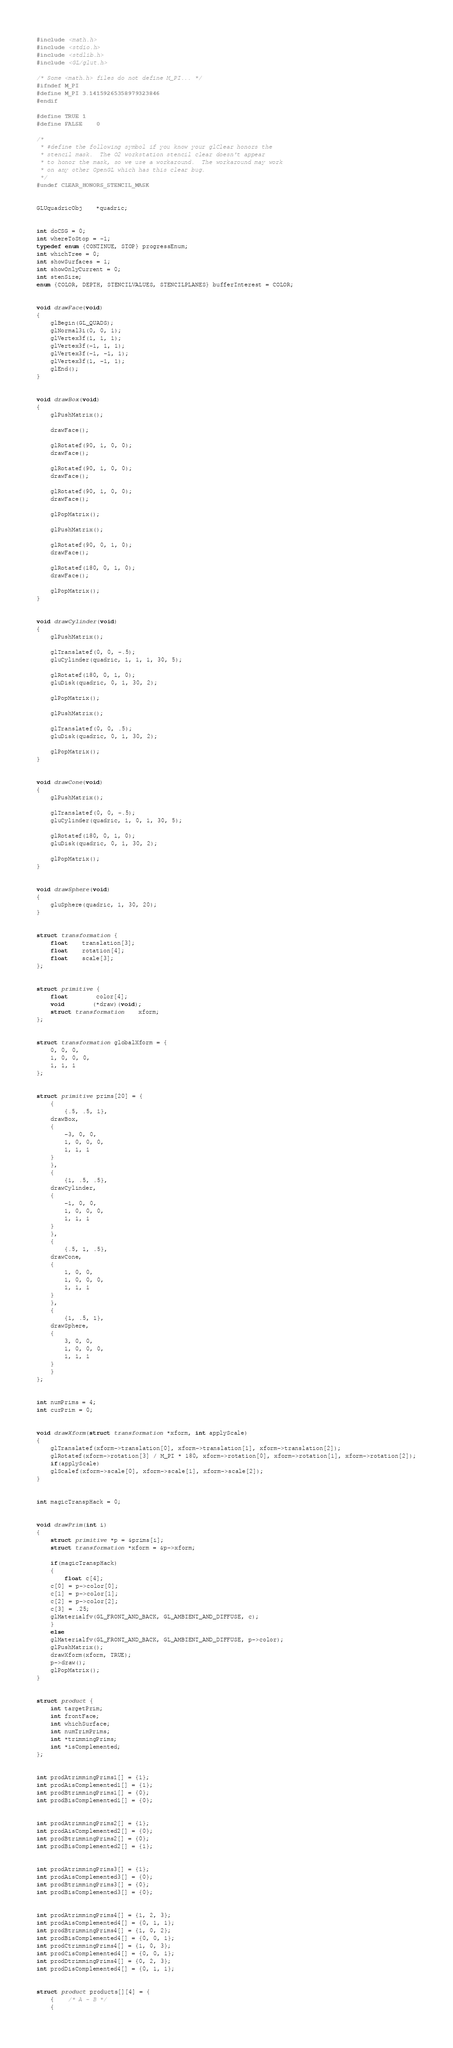<code> <loc_0><loc_0><loc_500><loc_500><_C_>#include <math.h>
#include <stdio.h>
#include <stdlib.h>
#include <GL/glut.h>

/* Some <math.h> files do not define M_PI... */
#ifndef M_PI
#define M_PI 3.14159265358979323846
#endif

#define TRUE	1
#define FALSE	0

/*
 * #define the following symbol if you know your glClear honors the
 * stencil mask.  The O2 workstation stencil clear doesn't appear
 * to honor the mask, so we use a workaround.  The workaround may work
 * on any other OpenGL which has this clear bug.
 */
#undef CLEAR_HONORS_STENCIL_MASK


GLUquadricObj	*quadric;


int doCSG = 0;
int whereToStop = -1;
typedef enum {CONTINUE, STOP} progressEnum;
int whichTree = 0;
int showSurfaces = 1;
int showOnlyCurrent = 0;
int stenSize;
enum {COLOR, DEPTH, STENCILVALUES, STENCILPLANES} bufferInterest = COLOR;


void drawFace(void)
{
    glBegin(GL_QUADS);
    glNormal3i(0, 0, 1);
    glVertex3f(1, 1, 1);
    glVertex3f(-1, 1, 1);
    glVertex3f(-1, -1, 1);
    glVertex3f(1, -1, 1);
    glEnd();
}


void drawBox(void)
{
    glPushMatrix();

    drawFace();

    glRotatef(90, 1, 0, 0);
    drawFace();

    glRotatef(90, 1, 0, 0);
    drawFace();

    glRotatef(90, 1, 0, 0);
    drawFace();

    glPopMatrix();

    glPushMatrix();

    glRotatef(90, 0, 1, 0);
    drawFace();

    glRotatef(180, 0, 1, 0);
    drawFace();

    glPopMatrix();
}


void drawCylinder(void)
{
    glPushMatrix();

    glTranslatef(0, 0, -.5);
    gluCylinder(quadric, 1, 1, 1, 30, 5);

    glRotatef(180, 0, 1, 0);
    gluDisk(quadric, 0, 1, 30, 2);

    glPopMatrix();

    glPushMatrix();

    glTranslatef(0, 0, .5);
    gluDisk(quadric, 0, 1, 30, 2);

    glPopMatrix();
}


void drawCone(void)
{
    glPushMatrix();

    glTranslatef(0, 0, -.5);
    gluCylinder(quadric, 1, 0, 1, 30, 5);

    glRotatef(180, 0, 1, 0);
    gluDisk(quadric, 0, 1, 30, 2);

    glPopMatrix();
}


void drawSphere(void)
{
    gluSphere(quadric, 1, 30, 20);
}


struct transformation {
    float	translation[3];
    float	rotation[4];
    float	scale[3];
};


struct primitive {
    float		color[4];
    void		(*draw)(void);
    struct transformation	xform;
};


struct transformation globalXform = {
    0, 0, 0,
    1, 0, 0, 0,
    1, 1, 1
};


struct primitive prims[20] = {
    {
        {.5, .5, 1},
	drawBox,
	{
	    -3, 0, 0,
	    1, 0, 0, 0,
	    1, 1, 1
	}
    },
    {
        {1, .5, .5},
	drawCylinder,
	{
	    -1, 0, 0,
	    1, 0, 0, 0,
	    1, 1, 1
	}
    },
    {
        {.5, 1, .5},
	drawCone,
	{
	    1, 0, 0,
	    1, 0, 0, 0,
	    1, 1, 1
	}
    },
    {
        {1, .5, 1},
	drawSphere,
	{
	    3, 0, 0,
	    1, 0, 0, 0,
	    1, 1, 1
	}
    }
};


int numPrims = 4;
int curPrim = 0;


void drawXform(struct transformation *xform, int applyScale)
{
    glTranslatef(xform->translation[0], xform->translation[1], xform->translation[2]);
    glRotatef(xform->rotation[3] / M_PI * 180, xform->rotation[0], xform->rotation[1], xform->rotation[2]);
    if(applyScale)
	glScalef(xform->scale[0], xform->scale[1], xform->scale[2]);
}


int magicTranspHack = 0;


void drawPrim(int i)
{
    struct primitive *p = &prims[i];
    struct transformation *xform = &p->xform;

    if(magicTranspHack)
    {
        float c[4];
	c[0] = p->color[0];
	c[1] = p->color[1];
	c[2] = p->color[2];
	c[3] = .25;
	glMaterialfv(GL_FRONT_AND_BACK, GL_AMBIENT_AND_DIFFUSE, c);
    }
    else
	glMaterialfv(GL_FRONT_AND_BACK, GL_AMBIENT_AND_DIFFUSE, p->color);
    glPushMatrix();
    drawXform(xform, TRUE);
    p->draw();
    glPopMatrix();
}


struct product {
    int targetPrim;
    int frontFace;
    int whichSurface;
    int numTrimPrims;
    int *trimmingPrims;
    int *isComplemented;
};


int prodAtrimmingPrims1[] = {1};
int prodAisComplemented1[] = {1};
int prodBtrimmingPrims1[] = {0};
int prodBisComplemented1[] = {0};


int prodAtrimmingPrims2[] = {1};
int prodAisComplemented2[] = {0};
int prodBtrimmingPrims2[] = {0};
int prodBisComplemented2[] = {1};


int prodAtrimmingPrims3[] = {1};
int prodAisComplemented3[] = {0};
int prodBtrimmingPrims3[] = {0};
int prodBisComplemented3[] = {0};


int prodAtrimmingPrims4[] = {1, 2, 3};
int prodAisComplemented4[] = {0, 1, 1};
int prodBtrimmingPrims4[] = {1, 0, 2};
int prodBisComplemented4[] = {0, 0, 1};
int prodCtrimmingPrims4[] = {1, 0, 3};
int prodCisComplemented4[] = {0, 0, 1};
int prodDtrimmingPrims4[] = {0, 2, 3};
int prodDisComplemented4[] = {0, 1, 1};


struct product products[][4] = {
    {	/* A - B */
	{</code> 